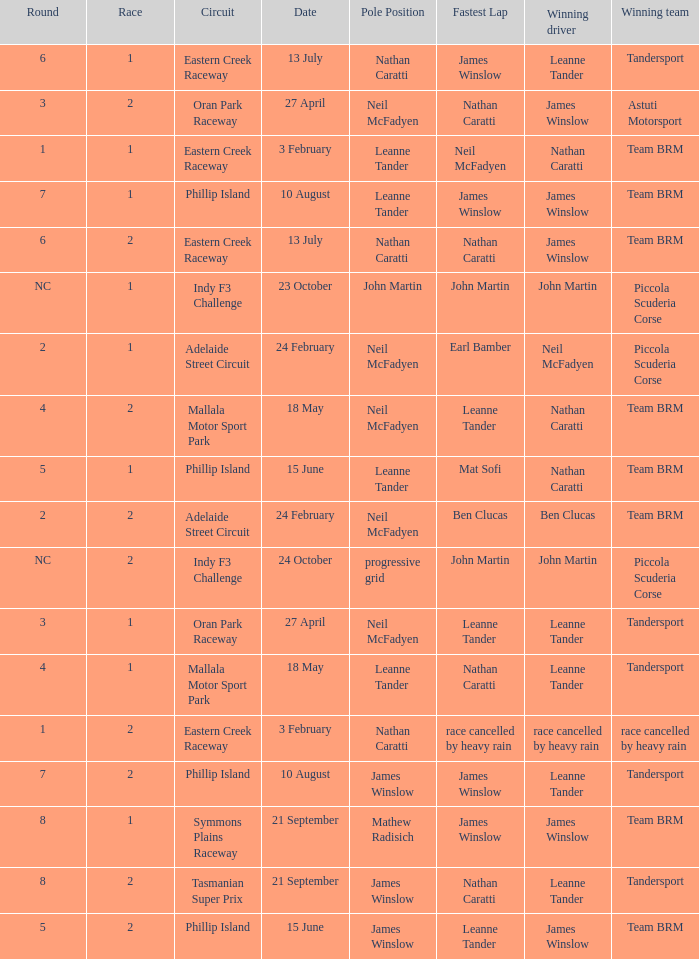What is the highest race number in the Phillip Island circuit with James Winslow as the winning driver and pole position? 2.0. 